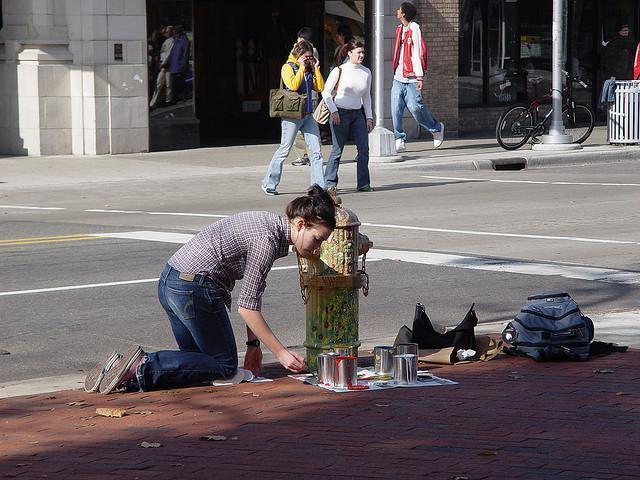What kind of brush is being used?
Select the accurate response from the four choices given to answer the question.
Options: Paint, hair, tooth, pet. Paint. 